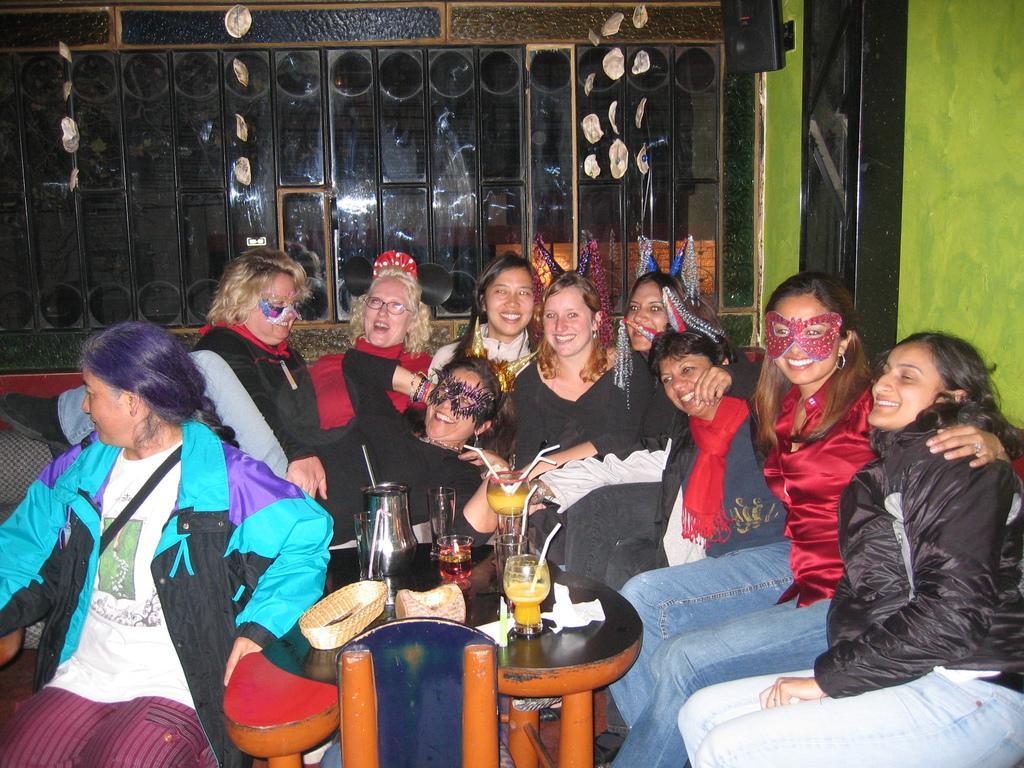Can you describe this image briefly? This picture is clicked inside. In the center there is a wooden table on the top of which glasses of drinks and some other items are placed and we can see the group of women smiling and sitting on the couch. In the background we can see the wall and some other items. 